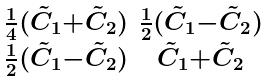<formula> <loc_0><loc_0><loc_500><loc_500>\begin{smallmatrix} \frac { 1 } { 4 } ( \tilde { C } _ { 1 } { + } \tilde { C } _ { 2 } ) & \frac { 1 } { 2 } ( \tilde { C } _ { 1 } { - } \tilde { C } _ { 2 } ) \\ \frac { 1 } { 2 } ( \tilde { C } _ { 1 } { - } \tilde { C } _ { 2 } ) & \tilde { C } _ { 1 } { + } \tilde { C } _ { 2 } \end{smallmatrix}</formula> 